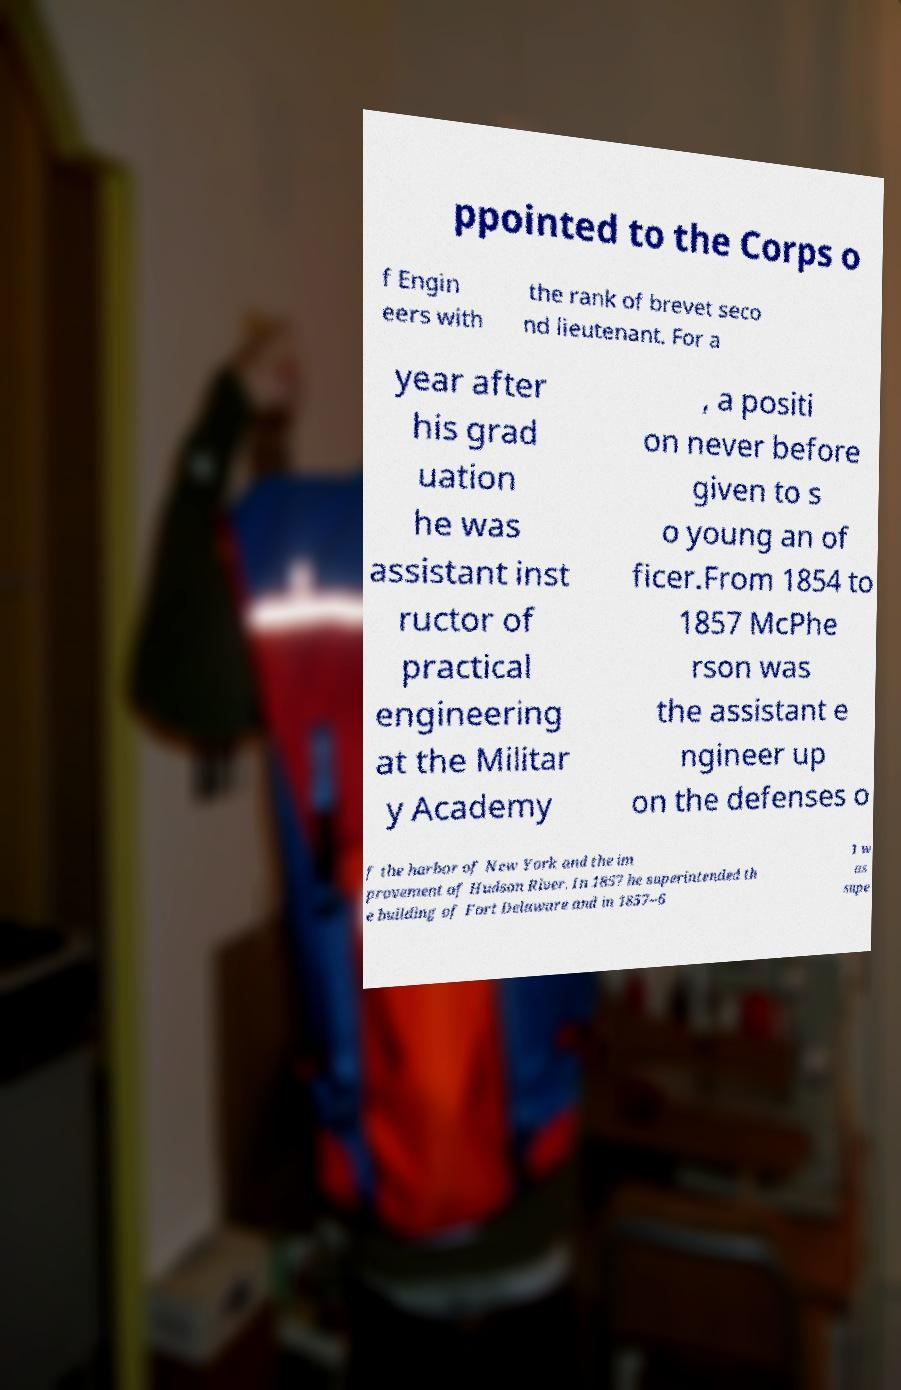There's text embedded in this image that I need extracted. Can you transcribe it verbatim? ppointed to the Corps o f Engin eers with the rank of brevet seco nd lieutenant. For a year after his grad uation he was assistant inst ructor of practical engineering at the Militar y Academy , a positi on never before given to s o young an of ficer.From 1854 to 1857 McPhe rson was the assistant e ngineer up on the defenses o f the harbor of New York and the im provement of Hudson River. In 1857 he superintended th e building of Fort Delaware and in 1857–6 1 w as supe 